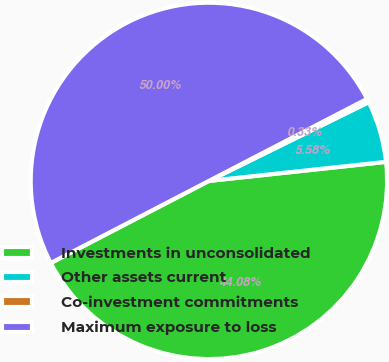Convert chart. <chart><loc_0><loc_0><loc_500><loc_500><pie_chart><fcel>Investments in unconsolidated<fcel>Other assets current<fcel>Co-investment commitments<fcel>Maximum exposure to loss<nl><fcel>44.08%<fcel>5.58%<fcel>0.33%<fcel>50.0%<nl></chart> 